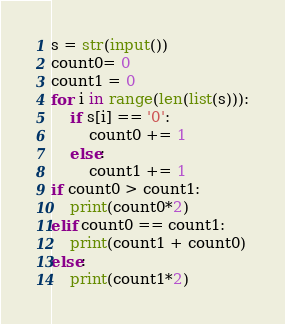Convert code to text. <code><loc_0><loc_0><loc_500><loc_500><_Python_>s = str(input())
count0= 0
count1 = 0
for i in range(len(list(s))):
    if s[i] == '0':
        count0 += 1
    else:
        count1 += 1
if count0 > count1:
    print(count0*2)
elif count0 == count1:
    print(count1 + count0)
else:
    print(count1*2)</code> 